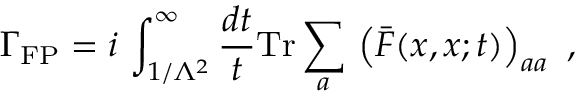Convert formula to latex. <formula><loc_0><loc_0><loc_500><loc_500>\Gamma _ { F P } = i \, \int _ { 1 / \Lambda ^ { 2 } } ^ { \infty } \frac { d t } { t } T r \sum _ { a } \, \left ( \bar { F } ( x , x ; t ) \right ) _ { a a } \ ,</formula> 